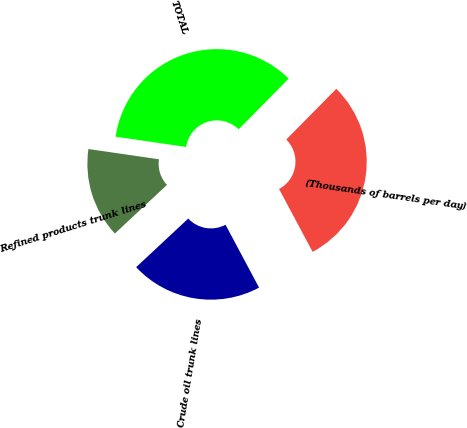Convert chart to OTSL. <chart><loc_0><loc_0><loc_500><loc_500><pie_chart><fcel>(Thousands of barrels per day)<fcel>Crude oil trunk lines<fcel>Refined products trunk lines<fcel>TOTAL<nl><fcel>29.8%<fcel>20.85%<fcel>14.25%<fcel>35.1%<nl></chart> 